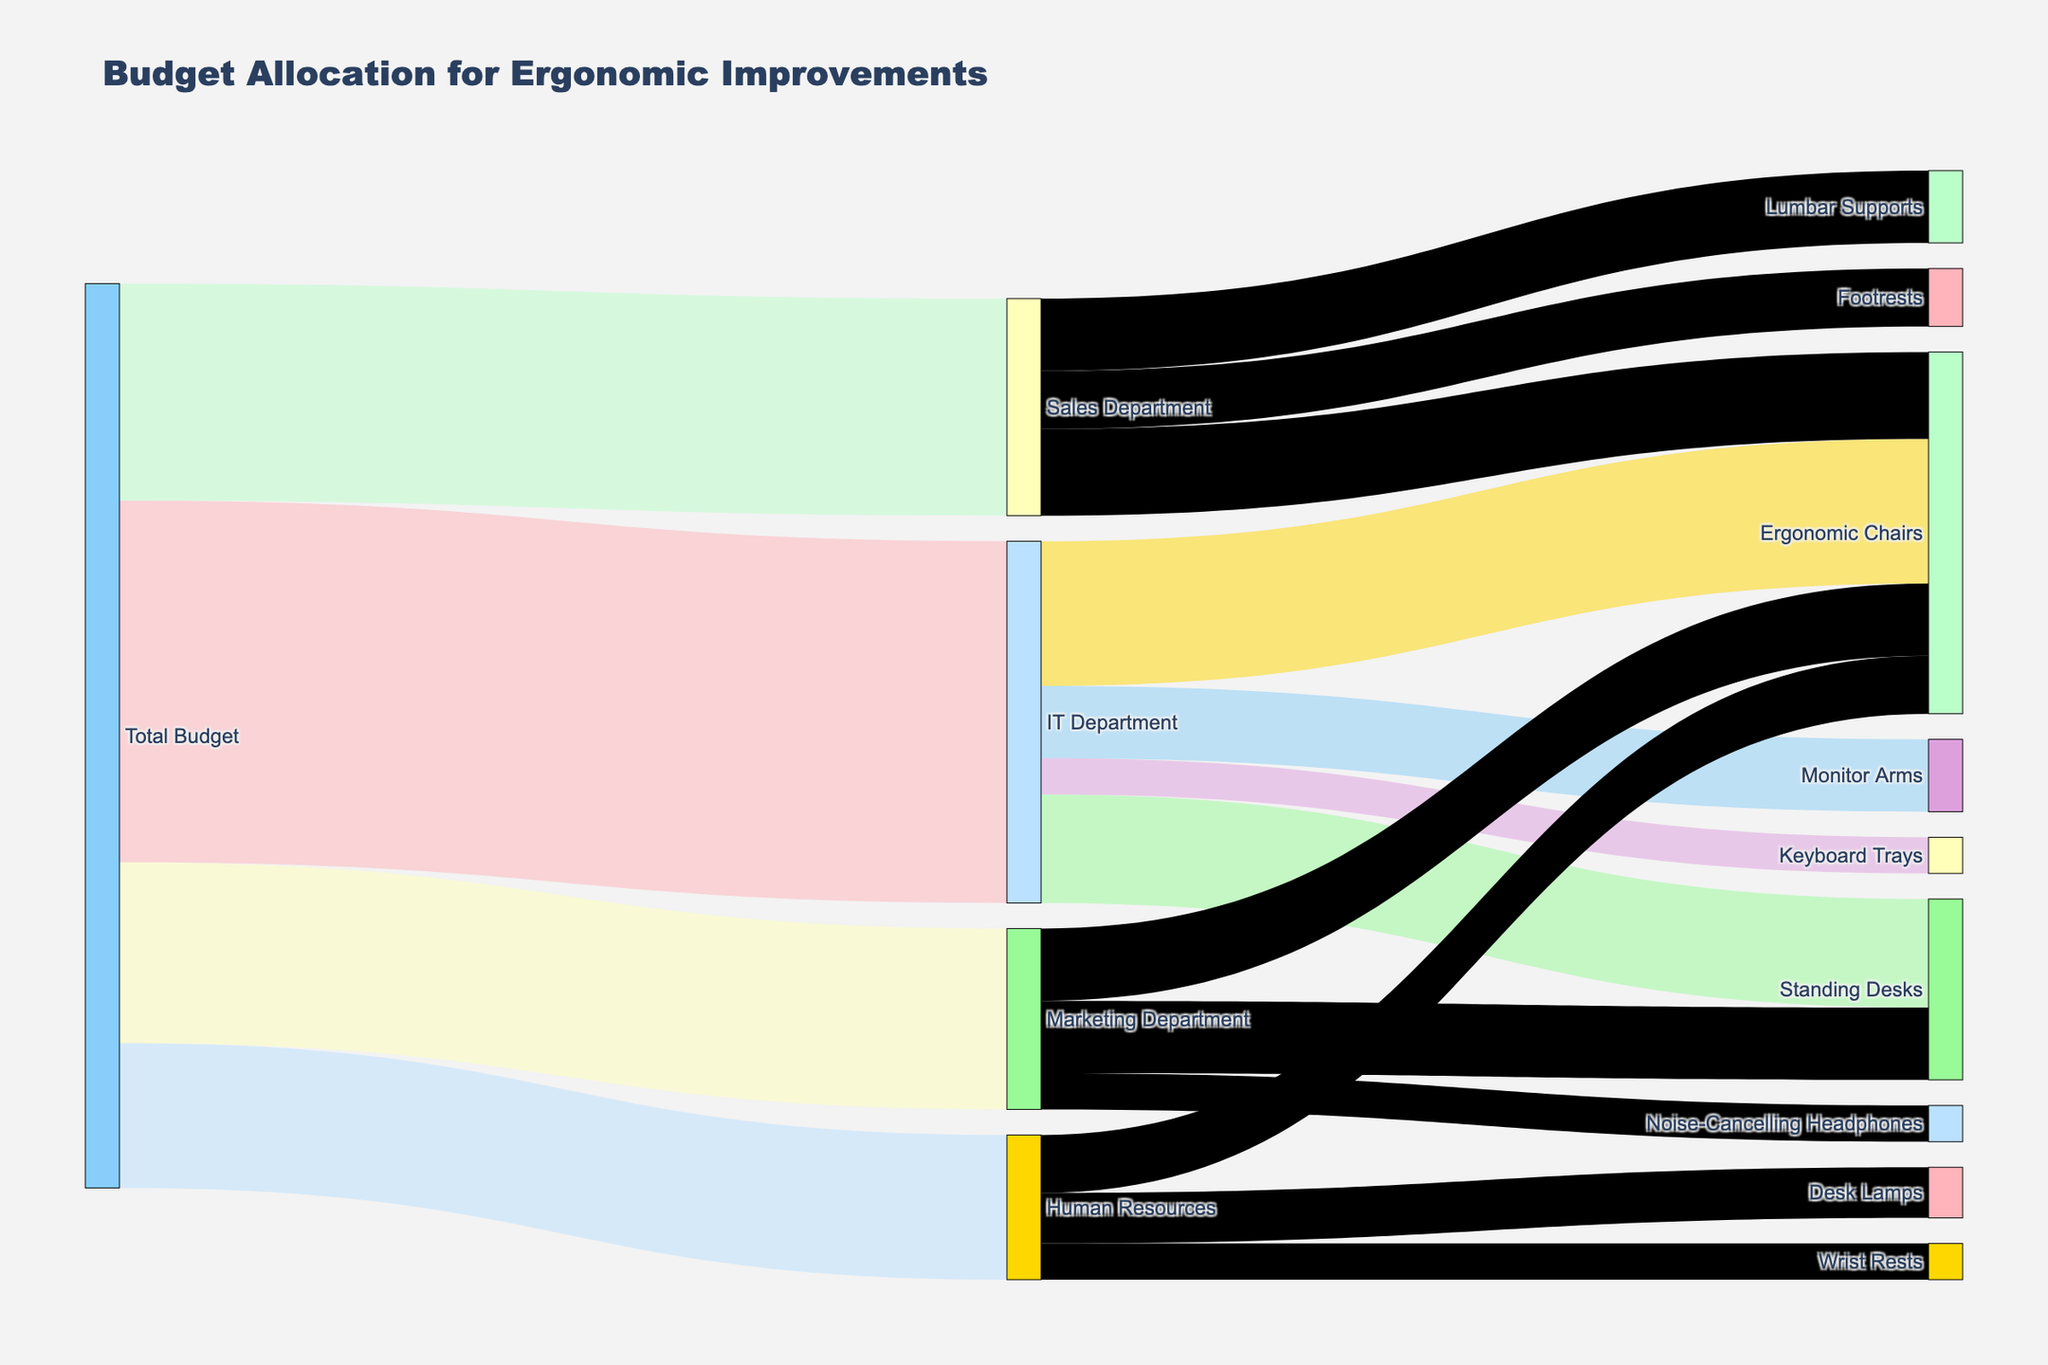How much total budget is allocated for ergonomic chairs across all departments? To find the total budget for ergonomic chairs, sum the values allocated to ergonomic chairs in each department: IT Department (20,000), Sales Department (12,000), Human Resources (8,000), and Marketing Department (10,000). Adding these together gives 20,000 + 12,000 + 8,000 + 10,000 = 50,000.
Answer: 50,000 Which department received the highest total budget allocation? To find the department with the highest allocation, compare the values: IT Department (50,000), Sales Department (30,000), Human Resources (20,000), and Marketing Department (25,000). The IT Department has the highest allocation.
Answer: IT Department How does the budget allocation for standing desks in the IT Department compare to that in the Marketing Department? Compare the values for standing desks in both departments: IT Department (15,000) and Marketing Department (10,000). The IT Department has a higher allocation.
Answer: IT Department Which specific equipment purchase has the highest allocation in the Human Resources department? Check the values for all equipment in the Human Resources department: Ergonomic Chairs (8,000), Desk Lamps (7,000), Wrist Rests (5,000). Ergonomic Chairs have the highest allocation.
Answer: Ergonomic Chairs What is the total budget allocated for monitor arms? The budget allocation for monitor arms identifies only one entry: IT Department (10,000).
Answer: 10,000 How much more budget is allocated to sales-related lumbar supports compared to sales-related footrests? Identify the values for lumbar supports (10,000) and footrests (8,000) in the Sales Department. The difference is 10,000 - 8,000 = 2,000.
Answer: 2,000 What proportion of the total budget is allocated to the Marketing Department? The total budget is 125,000 (sum of all department allocations: 50,000 + 30,000 + 20,000 + 25,000). The Marketing Department's share is 25,000 / 125,000 = 0.2 or 20%.
Answer: 20% How many different types of equipment are budgeted for by the Sales Department? Count the unique equipment types under the Sales Department: Ergonomic Chairs, Footrests, and Lumbar Supports. There are three types.
Answer: 3 